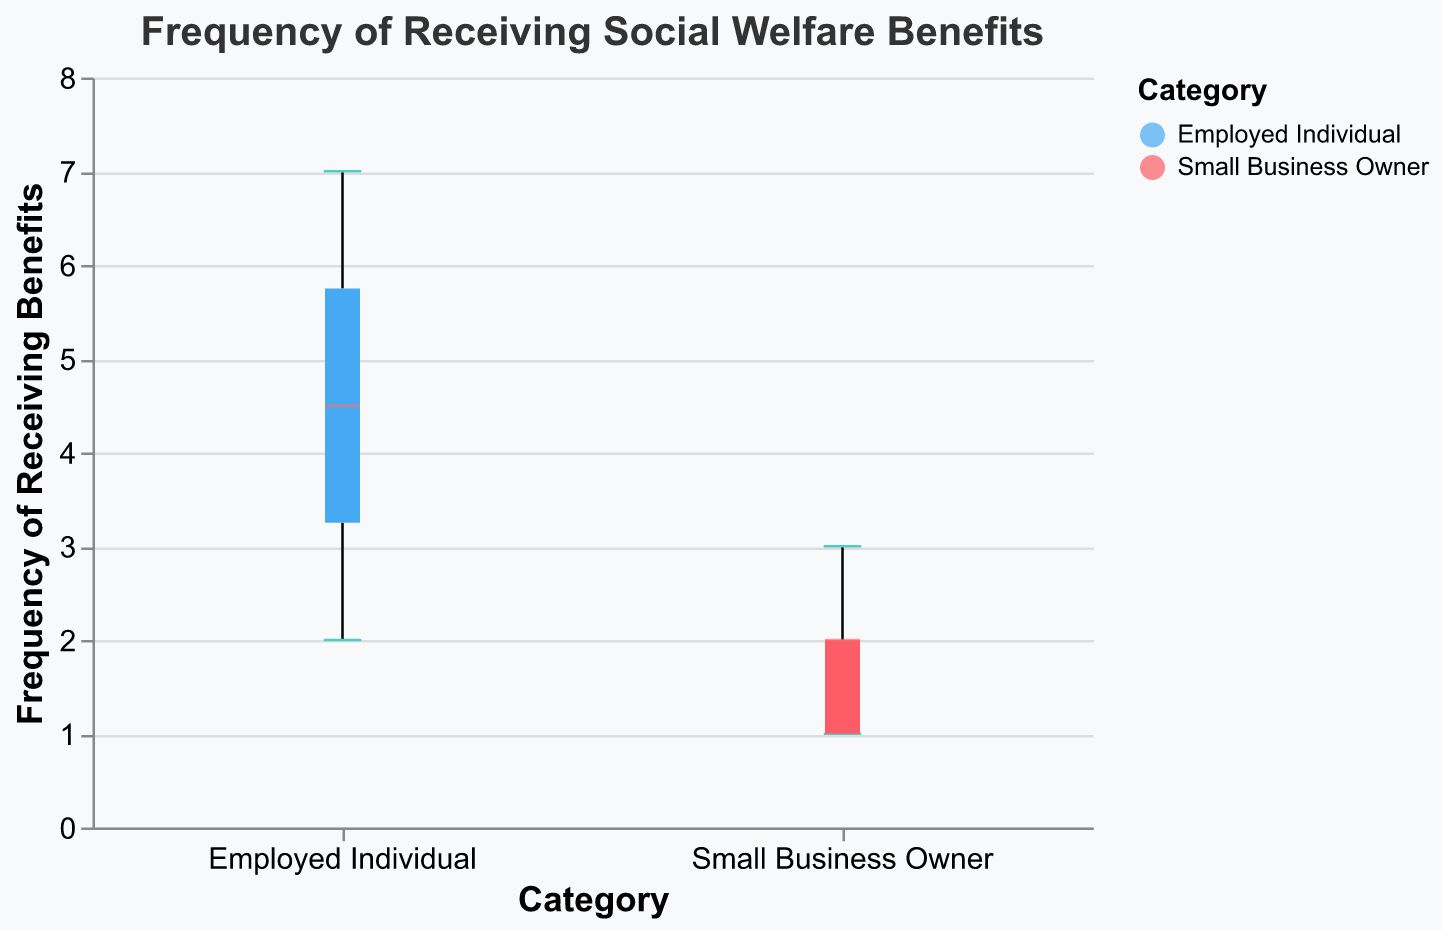What is the title of the figure? The title of the figure is located at the top and provides a description of what the figure represents. Here, the title is "Frequency of Receiving Social Welfare Benefits".
Answer: Frequency of Receiving Social Welfare Benefits What are the two categories shown on the x-axis? The x-axis displays the categories under comparison. In this figure, the two categories are "Employed Individual" and "Small Business Owner".
Answer: Employed Individual, Small Business Owner What is the range of the y-axis? The range of the y-axis is indicated by the minimum and maximum values. In this figure, the y-axis ranges from 0 to 8, as indicated by the domain in the axis configuration.
Answer: 0 to 8 What is the median frequency of receiving benefits for Employed Individuals? The median frequency is represented by a line within the box in a box plot. According to the box plot for Employed Individuals, the median frequency is 4.5, which is the point where 50% of observations are below and 50% are above.
Answer: 4.5 Which category has the highest maximum frequency of receiving benefits? By observing the upper extremities of the box plots, we can determine the maximum frequency. The maximum frequency for Employed Individuals is 7, whereas for Small Business Owners it is 3. Therefore, Employed Individuals have the highest maximum frequency.
Answer: Employed Individuals What is the interquartile range (IQR) of the frequency for Small Business Owners? The interquartile range (IQR) is the difference between the third quartile (Q3) and the first quartile (Q1). For Small Business Owners, Q3 is 2.5 and Q1 is 1. Therefore, IQR is 2.5 - 1 = 1.5.
Answer: 1.5 Which group shows a wider spread in the frequency of receiving benefits? The spread can be estimated by looking at the range of the data. Employed Individuals have a wider range from 2 to 7, while Small Business Owners have a range from 1 to 3. Thus, Employed Individuals show a wider spread.
Answer: Employed Individuals What is the lower quartile (Q1) value for Employed Individuals? The lower quartile (Q1) value is the value below which 25% of the data falls. For Employed Individuals, Q1 is 3.5.
Answer: 3.5 Which group appears to have a lower overall frequency of receiving benefits? A lower overall frequency can be indicated by lower median and quartile values. Small Business Owners tend to have lower frequency values overall, with a lower median and lower quartiles compared to Employed Individuals.
Answer: Small Business Owners What is the difference between the median frequencies of the two groups? The median frequency for Employed Individuals is 4.5, and for Small Business Owners, it is 2. The difference between these medians is 4.5 - 2 = 2.5.
Answer: 2.5 